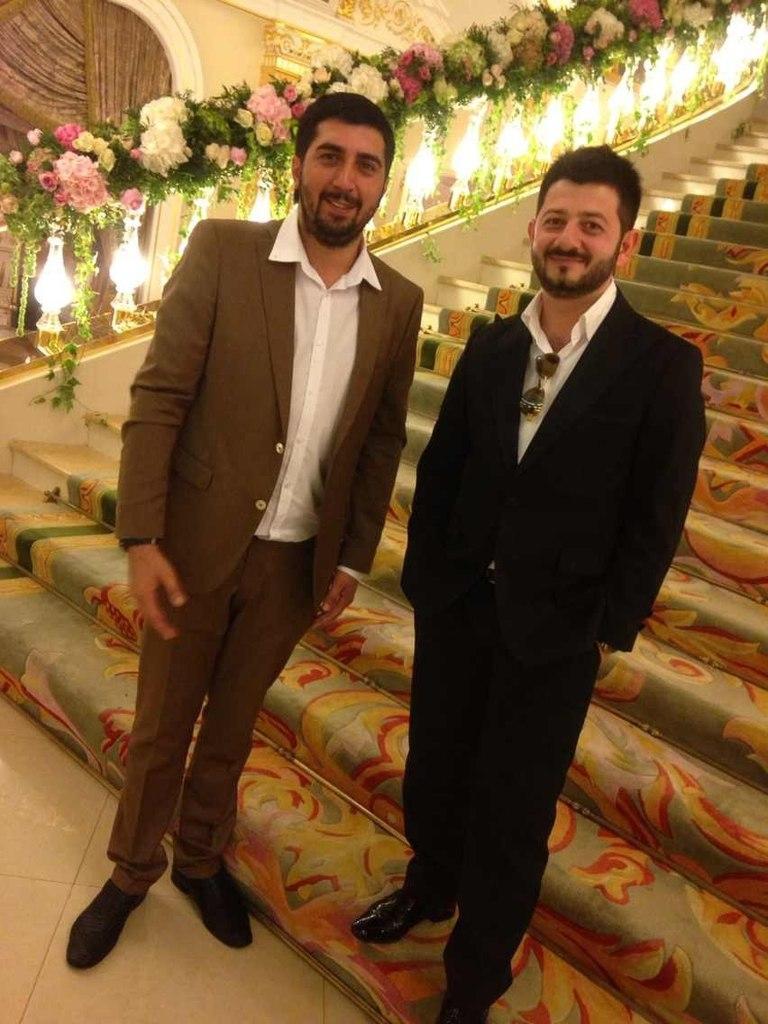In one or two sentences, can you explain what this image depicts? In the picture I can see two men standing on the floor and there is a smile on their faces. I can see two men wearing a suit. I can see the carpet on the staircase. There are flowers at the top of the picture. There is a curtain on the top left side of the picture. 